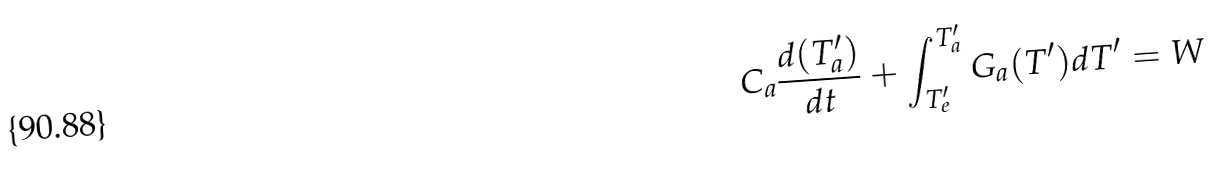Convert formula to latex. <formula><loc_0><loc_0><loc_500><loc_500>C _ { a } \frac { d ( T ^ { \prime } _ { a } ) } { d t } + \int _ { T ^ { \prime } _ { e } } ^ { T ^ { \prime } _ { a } } G _ { a } ( T ^ { \prime } ) d T ^ { \prime } = W</formula> 